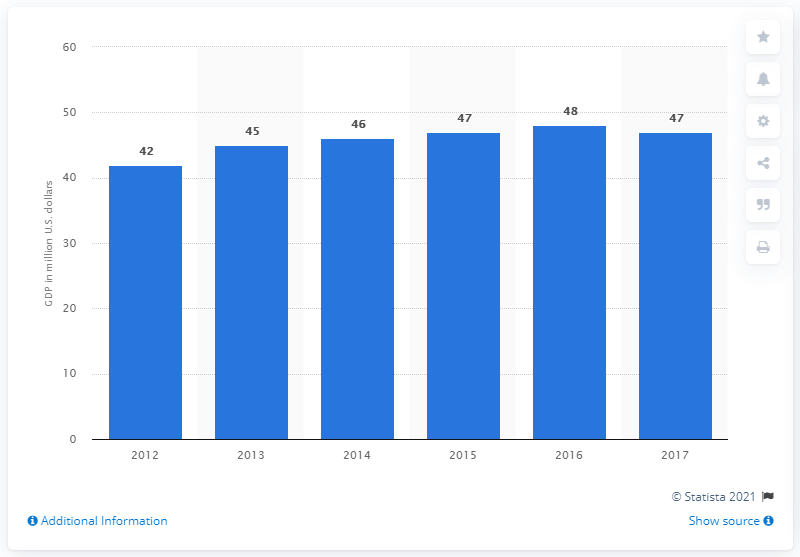Give some essential details in this illustration. The Gross Domestic Product (GDP) of Saba in 2016 was approximately 48 million. According to available data, the Gross Domestic Product (GDP) of Saba in 2012 was 42.. The Gross Domestic Product (GDP) of Saba in 2017 was approximately 47. 